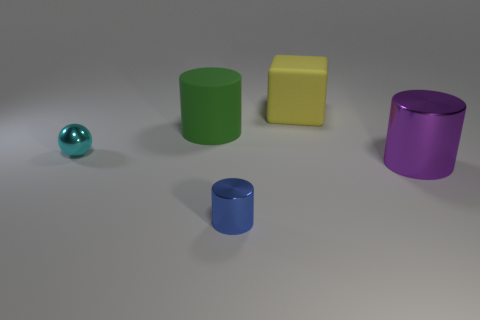What number of rubber things are large cubes or red things?
Your response must be concise. 1. Is the number of big rubber cylinders less than the number of large cylinders?
Make the answer very short. Yes. What number of other objects are there of the same material as the ball?
Provide a succinct answer. 2. The purple object that is the same shape as the blue thing is what size?
Your response must be concise. Large. Are the large thing left of the matte cube and the small cylinder in front of the large rubber block made of the same material?
Provide a succinct answer. No. Is the number of objects on the right side of the small cylinder less than the number of yellow rubber blocks?
Ensure brevity in your answer.  No. Is there any other thing that has the same shape as the cyan metal object?
Keep it short and to the point. No. There is another tiny metal thing that is the same shape as the green thing; what color is it?
Your response must be concise. Blue. There is a blue shiny cylinder that is in front of the green rubber cylinder; is it the same size as the green object?
Keep it short and to the point. No. How big is the thing on the left side of the matte object that is on the left side of the tiny blue metallic object?
Make the answer very short. Small. 